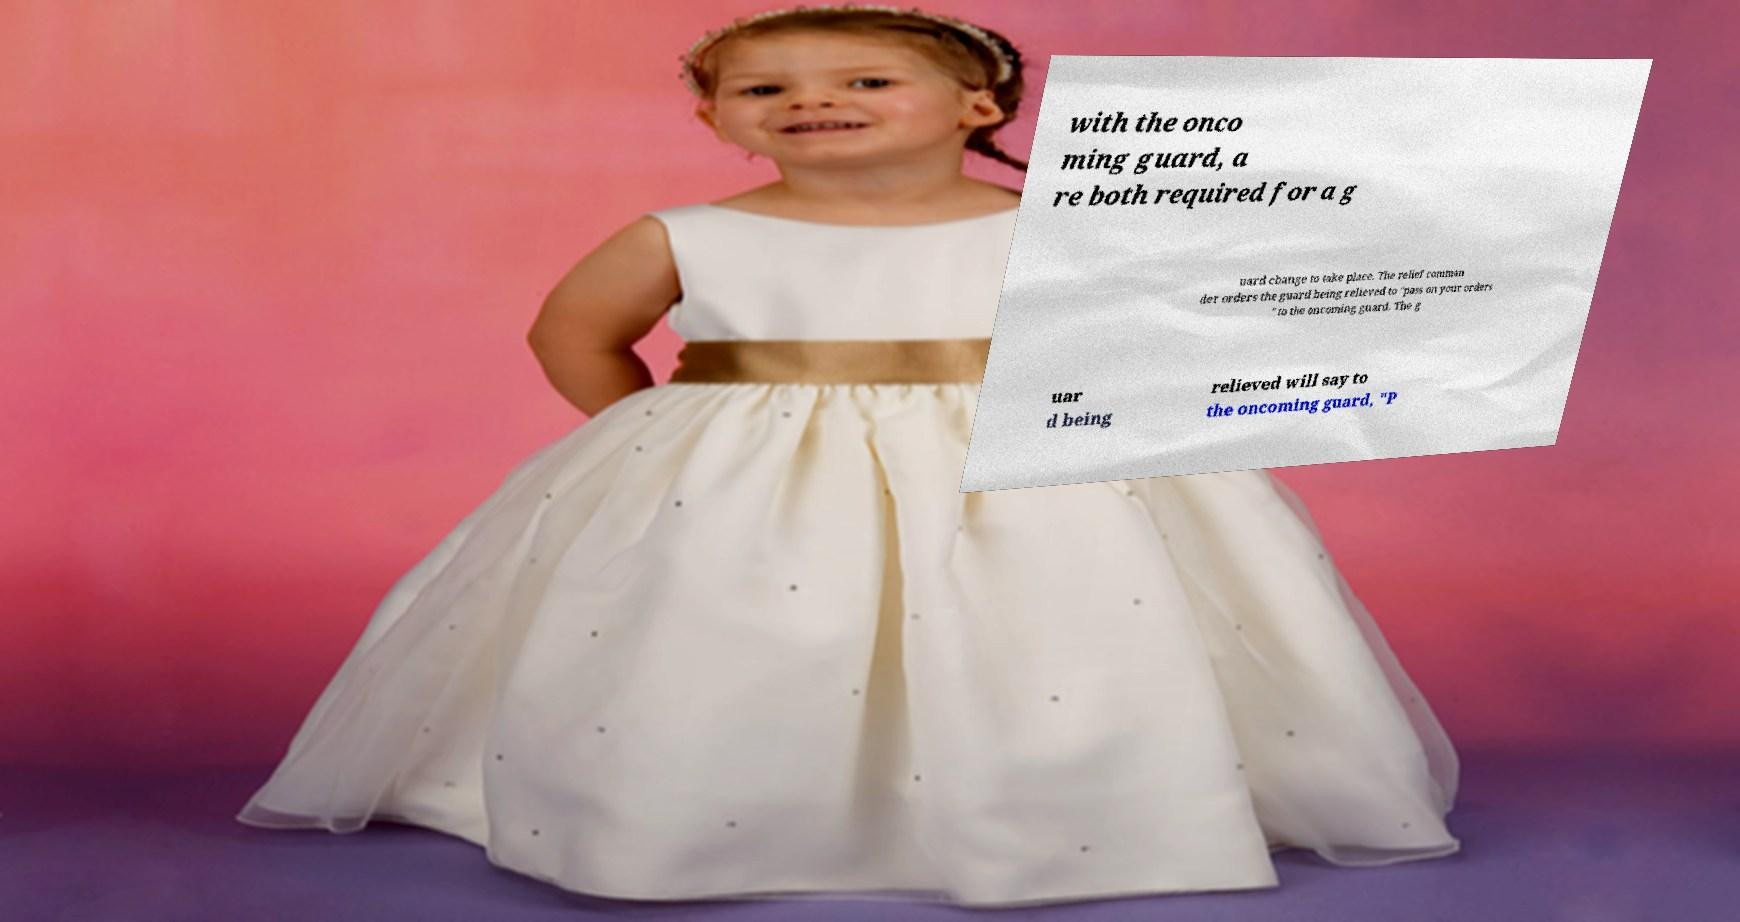Please read and relay the text visible in this image. What does it say? with the onco ming guard, a re both required for a g uard change to take place. The relief comman der orders the guard being relieved to "pass on your orders " to the oncoming guard. The g uar d being relieved will say to the oncoming guard, "P 